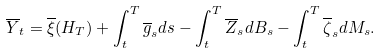Convert formula to latex. <formula><loc_0><loc_0><loc_500><loc_500>\overline { Y } _ { t } = \overline { \xi } ( H _ { T } ) + \int _ { t } ^ { T } \overline { g } _ { s } d s - \int _ { t } ^ { T } \overline { Z } _ { s } d B _ { s } - \int _ { t } ^ { T } \overline { \zeta } _ { s } d M _ { s } .</formula> 